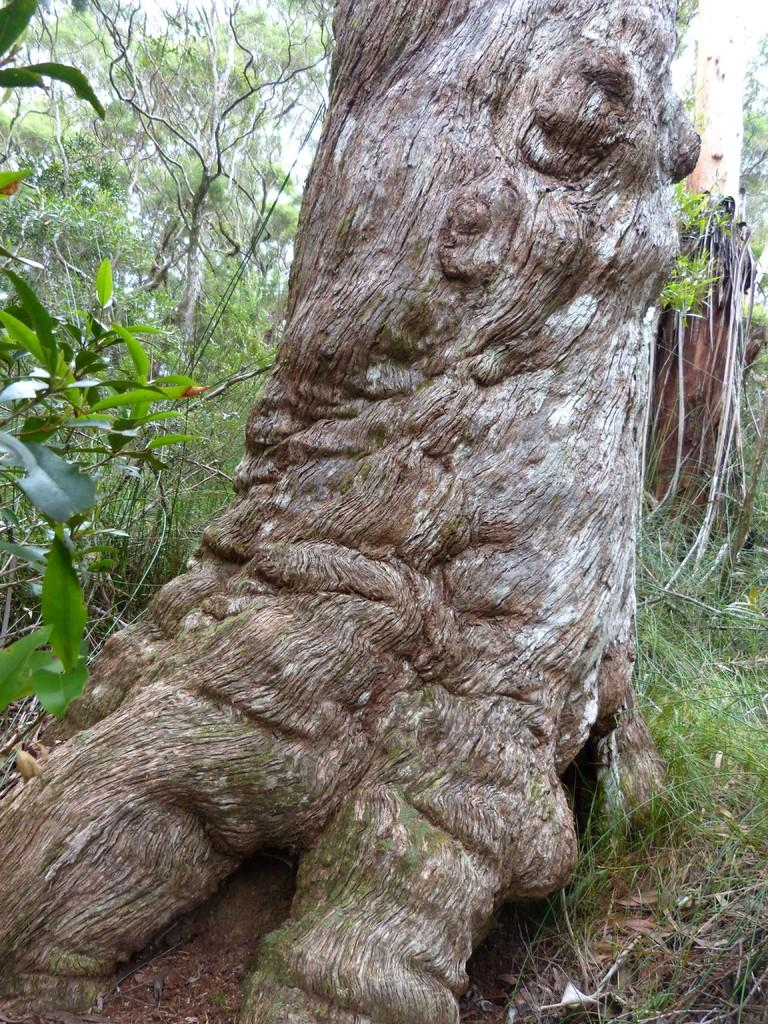What type of vegetation can be seen in the image? There are trees, plants, and grass visible in the image. Can you describe the ground in the image? The ground in the image is covered with grass. What other natural elements can be seen in the image? There are trees and plants visible in the image. What type of canvas is being used to paint the trees in the image? There is no canvas or painting present in the image; it is a photograph of real trees, plants, and grass. Can you tell me how the cook is preparing the plants in the image? There is no cook or preparation of plants visible in the image. 